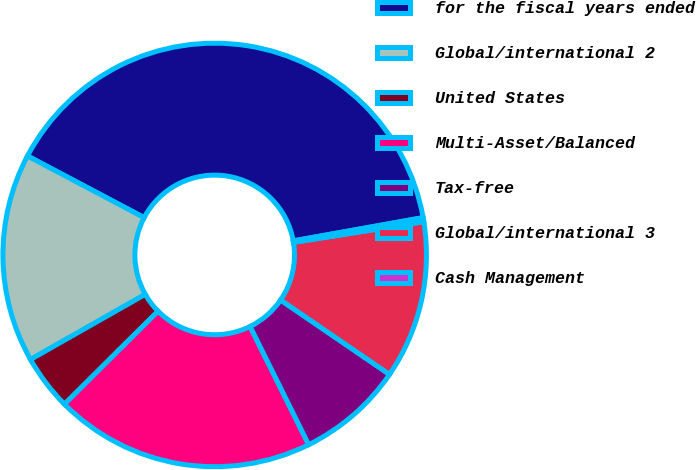Convert chart to OTSL. <chart><loc_0><loc_0><loc_500><loc_500><pie_chart><fcel>for the fiscal years ended<fcel>Global/international 2<fcel>United States<fcel>Multi-Asset/Balanced<fcel>Tax-free<fcel>Global/international 3<fcel>Cash Management<nl><fcel>39.44%<fcel>15.96%<fcel>4.23%<fcel>19.87%<fcel>8.14%<fcel>12.05%<fcel>0.31%<nl></chart> 